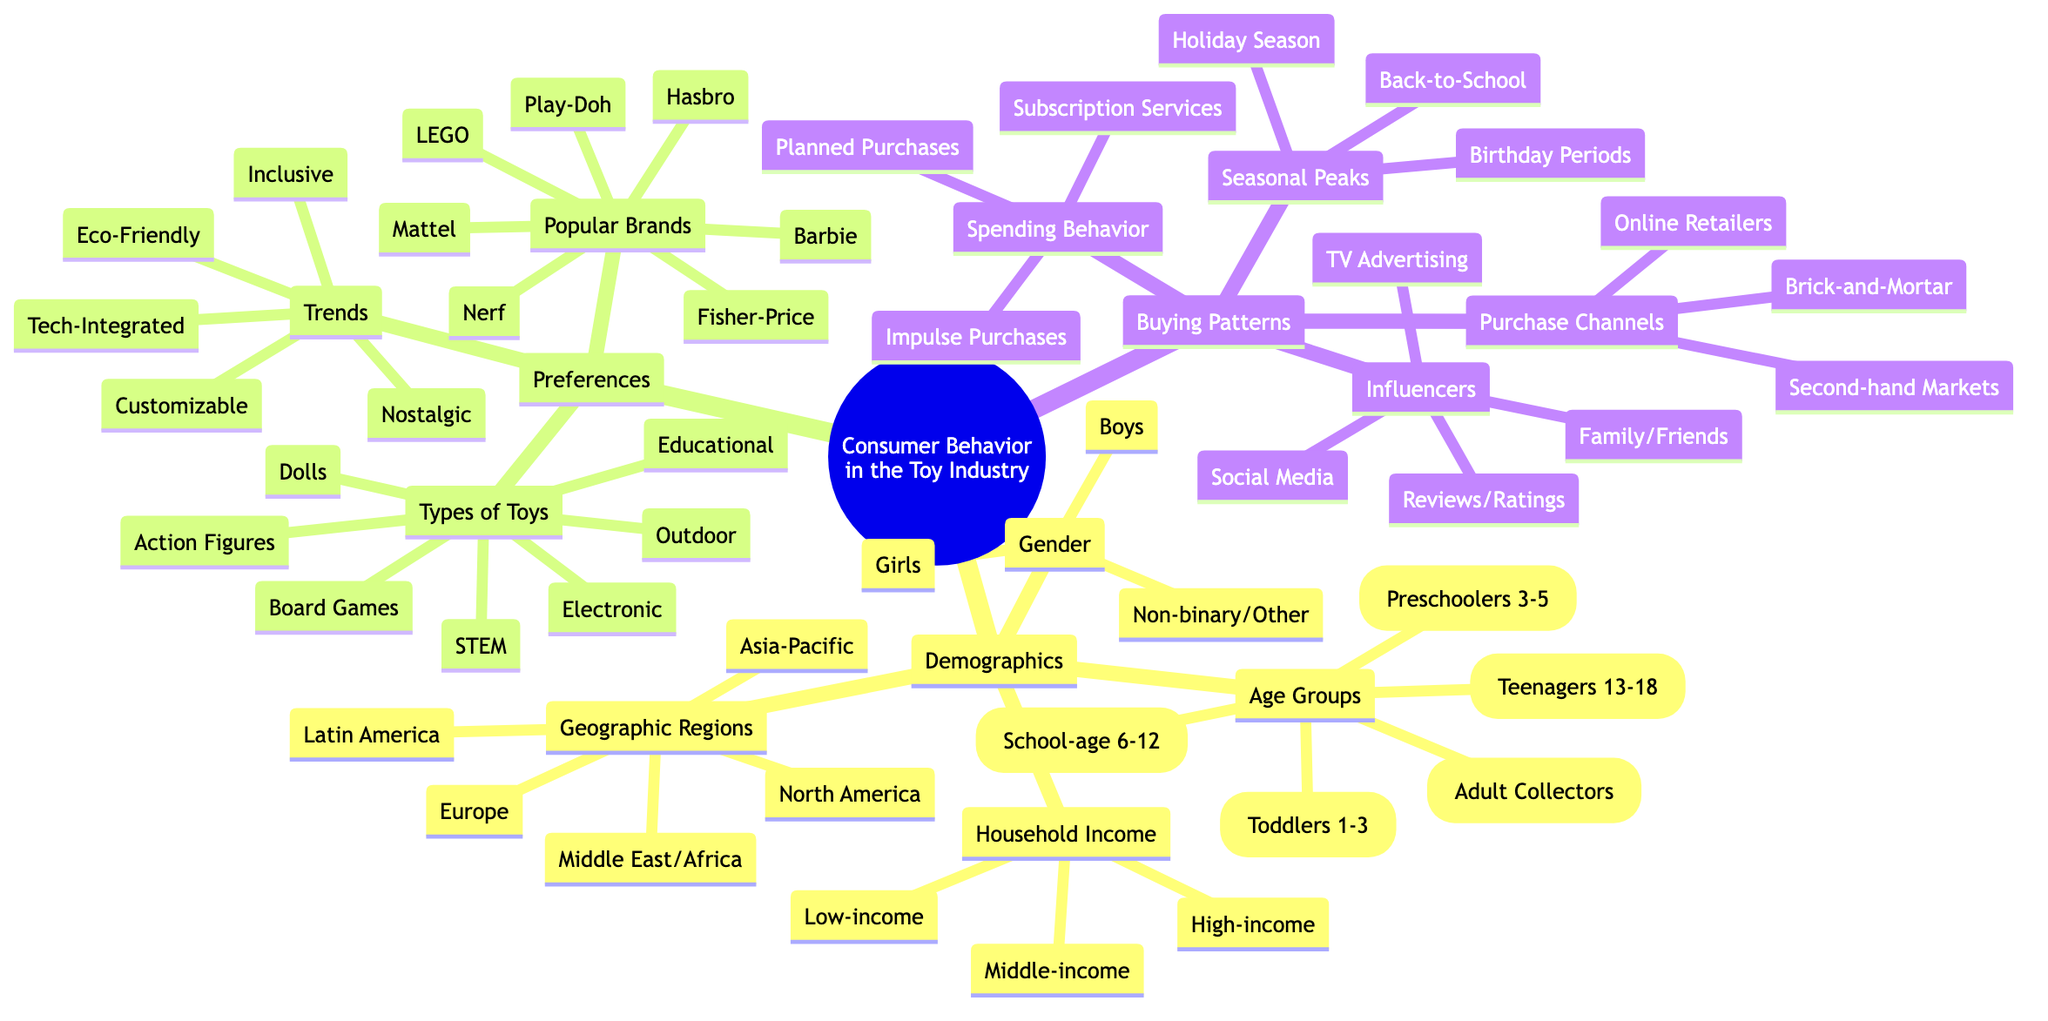What is the central topic of the mind map? The central topic is explicitly stated at the root of the mind map, which is "Consumer Behavior in the Toy Industry".
Answer: Consumer Behavior in the Toy Industry How many age groups are listed under demographics? There are five age groups mentioned under demographics: Toddlers, Preschoolers, School-age Children, Teenagers, and Adult Collectors. Counting them reveals the total number.
Answer: 5 Which geographic region is not included in the demographics section? By examining the listed geographic regions under demographics, we see that North America, Europe, Asia-Pacific, Latin America, and the Middle East/Africa are included. Regions like Antarctica or specific country names are missing.
Answer: Antarctica What type of toy is the least mentioned in the preferences section? The preferences section lists several types of toys and comparing them helps identify that "Outdoor Toys" is less popular among the listed categories compared to others.
Answer: Outdoor Toys Which influencer category appears last in the buying patterns? The buying patterns section lists categories of influencers, and the last one mentioned is "Reviews and Ratings", which we can confirm as we scroll through the section.
Answer: Reviews and Ratings Which age group do adult collectors belong to? Adult collectors do not belong to any specific younger age group as they are classified separately in the demographics section, indicating that they are a distinct group.
Answer: Adult Collectors How many trends are listed under preferences? By reviewing the trends subsection, we see five distinct trends noted: Eco-Friendly Toys, Customizable Toys, Technology-Integrated Toys, Nostalgic Toys, and Inclusive Toys. Counting them gives us the total.
Answer: 5 Which purchase channel is first listed under buying patterns? The buying patterns section starts with "Online Retailers", which is the first purchase channel listed when examining the hierarchy.
Answer: Online Retailers Which category has the most subcategories? Looking closely at the categories, "Demographics" includes four subcategories: Age Groups, Gender, Geographic Regions, and Household Income Levels. This is more than the other categories, making it the one with the most subcategories.
Answer: Demographics 